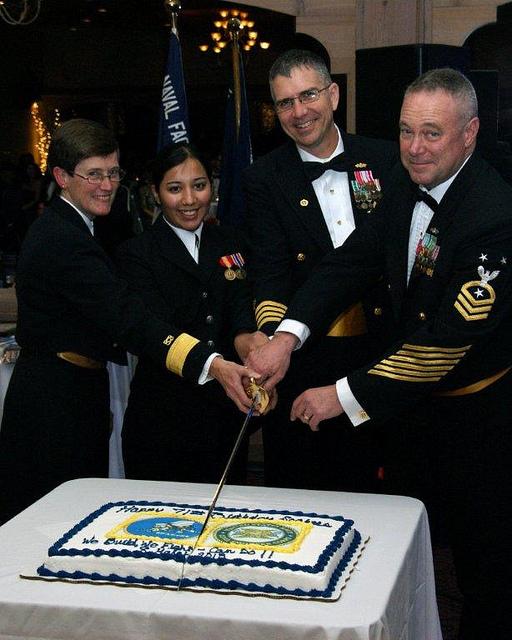How many people are wearing glasses?
Short answer required. 2. How many people are cutting the cake?
Concise answer only. 4. Is it someone's birthday?
Answer briefly. No. 